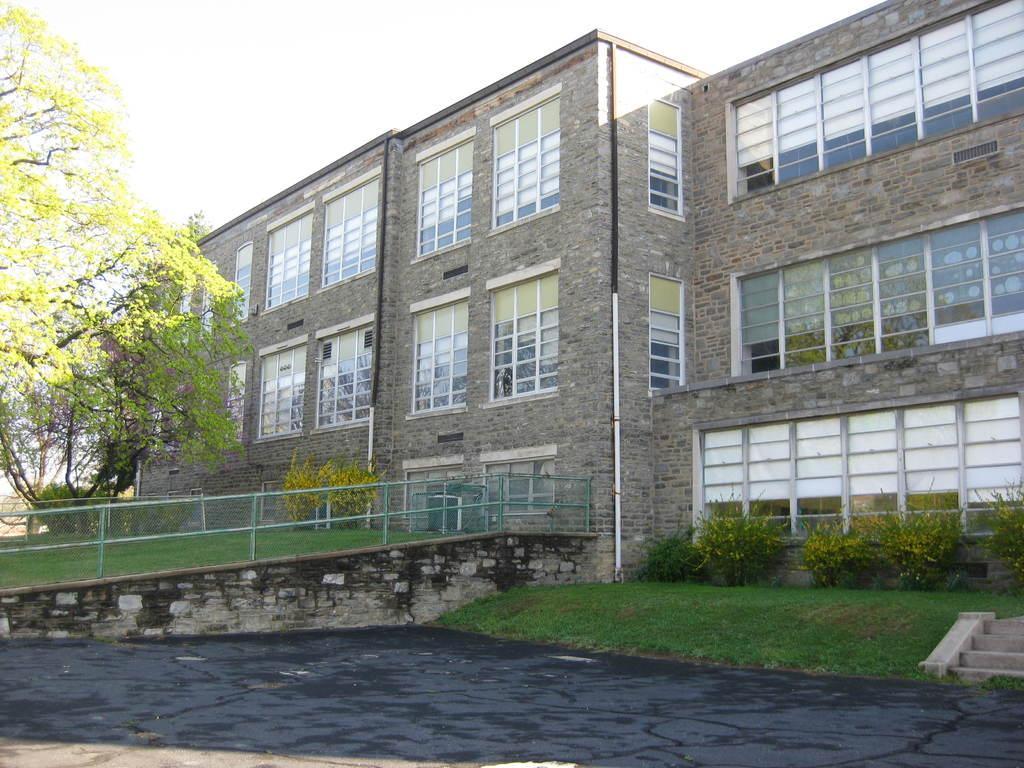Can you describe this image briefly? In this image, on the right side, we can see a building, glass window. On the right side, we can also see some plants. On the left side, we can see some trees, metal rod, grass. In the middle of the image, we can see water in a lake. On the right side, we can see a staircase. In the background, we can see few plants and a grass. 